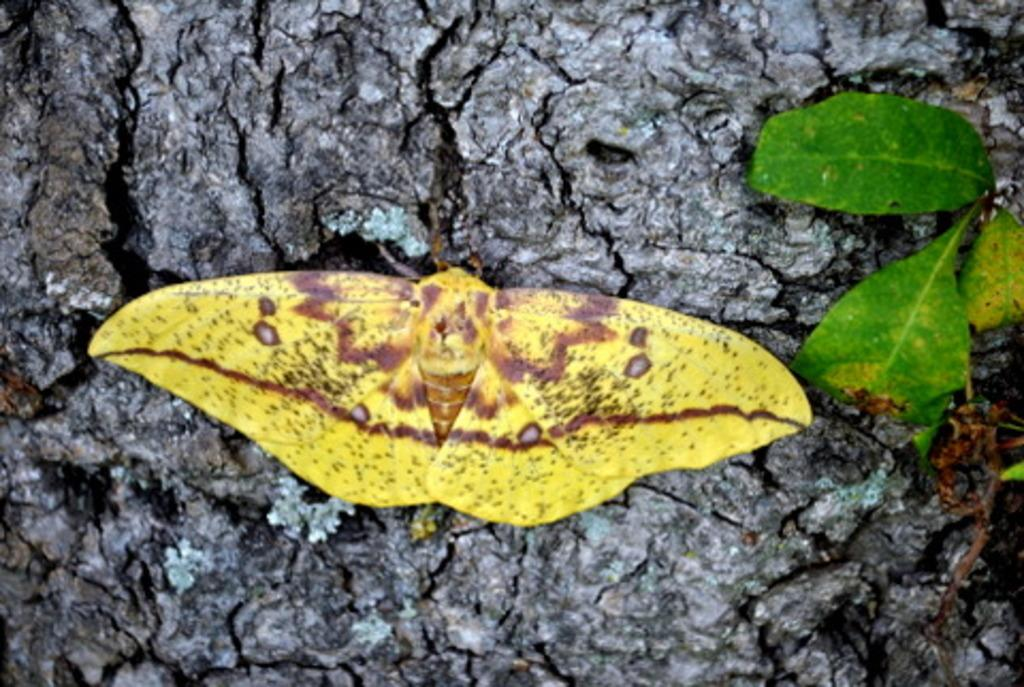What type of creature is present in the image? The image contains a butterfly. What is the butterfly doing in the image? The butterfly is laying on a surface. Can you describe the perspective of the image? The image is a zoomed-in view of the butterfly. What type of orange can be seen in the image? There is no orange present in the image; it features a butterfly laying on a surface. What type of arch is visible in the image? There is no arch present in the image. 